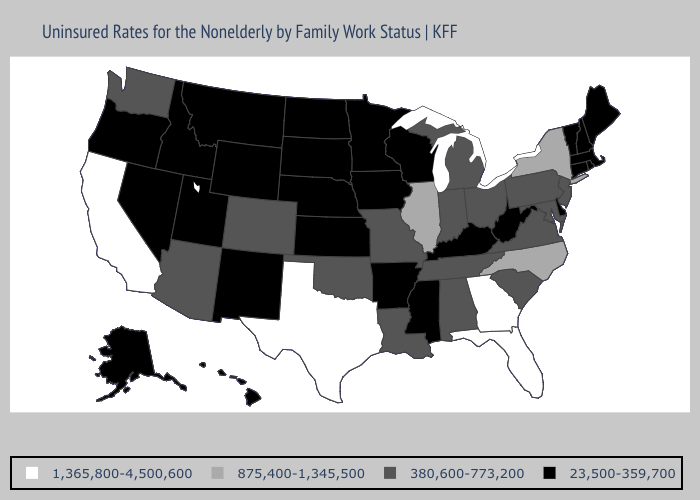What is the value of Florida?
Write a very short answer. 1,365,800-4,500,600. Does Louisiana have a lower value than Mississippi?
Be succinct. No. What is the highest value in the USA?
Be succinct. 1,365,800-4,500,600. Name the states that have a value in the range 380,600-773,200?
Quick response, please. Alabama, Arizona, Colorado, Indiana, Louisiana, Maryland, Michigan, Missouri, New Jersey, Ohio, Oklahoma, Pennsylvania, South Carolina, Tennessee, Virginia, Washington. What is the lowest value in states that border Utah?
Answer briefly. 23,500-359,700. What is the lowest value in the MidWest?
Write a very short answer. 23,500-359,700. Among the states that border New Mexico , which have the lowest value?
Quick response, please. Utah. Does Ohio have a lower value than Illinois?
Give a very brief answer. Yes. Does Michigan have the same value as South Carolina?
Answer briefly. Yes. What is the highest value in the USA?
Concise answer only. 1,365,800-4,500,600. What is the value of Oregon?
Give a very brief answer. 23,500-359,700. Does Idaho have the same value as South Dakota?
Give a very brief answer. Yes. Among the states that border Arizona , which have the highest value?
Be succinct. California. Which states hav the highest value in the West?
Answer briefly. California. 